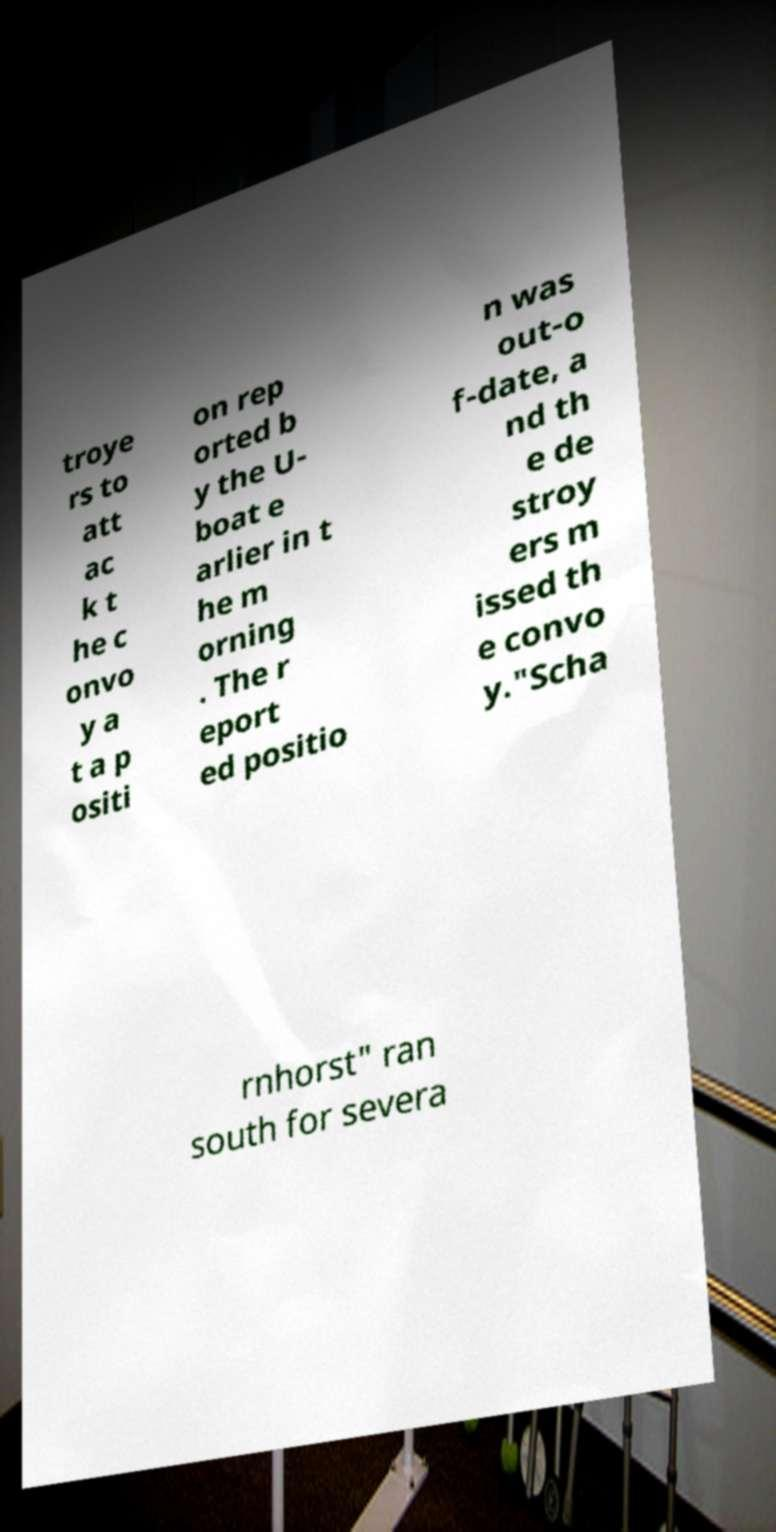What messages or text are displayed in this image? I need them in a readable, typed format. troye rs to att ac k t he c onvo y a t a p ositi on rep orted b y the U- boat e arlier in t he m orning . The r eport ed positio n was out-o f-date, a nd th e de stroy ers m issed th e convo y."Scha rnhorst" ran south for severa 